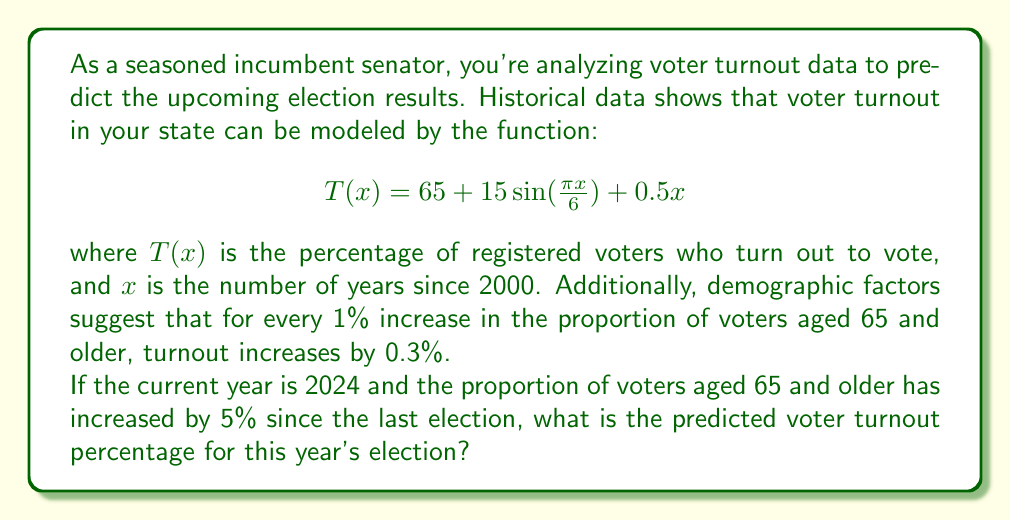Show me your answer to this math problem. To solve this problem, we'll follow these steps:

1. Calculate the value of $x$ for 2024:
   2024 - 2000 = 24 years

2. Plug $x = 24$ into the voter turnout function:
   $$T(24) = 65 + 15\sin(\frac{\pi \cdot 24}{6}) + 0.5 \cdot 24$$

3. Simplify the expression:
   $$T(24) = 65 + 15\sin(4\pi) + 12$$
   $$T(24) = 65 + 15 \cdot 0 + 12$$ (since $\sin(4\pi) = 0$)
   $$T(24) = 77$$

4. Account for the demographic shift:
   5% increase in voters aged 65 and older
   0.3% increase in turnout for each 1% increase in older voters
   Total increase due to demographics = $5 \cdot 0.3 = 1.5\%$

5. Add the demographic increase to the base turnout:
   $77\% + 1.5\% = 78.5\%$

Therefore, the predicted voter turnout for the 2024 election is 78.5%.
Answer: 78.5% 